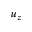<formula> <loc_0><loc_0><loc_500><loc_500>u _ { z }</formula> 